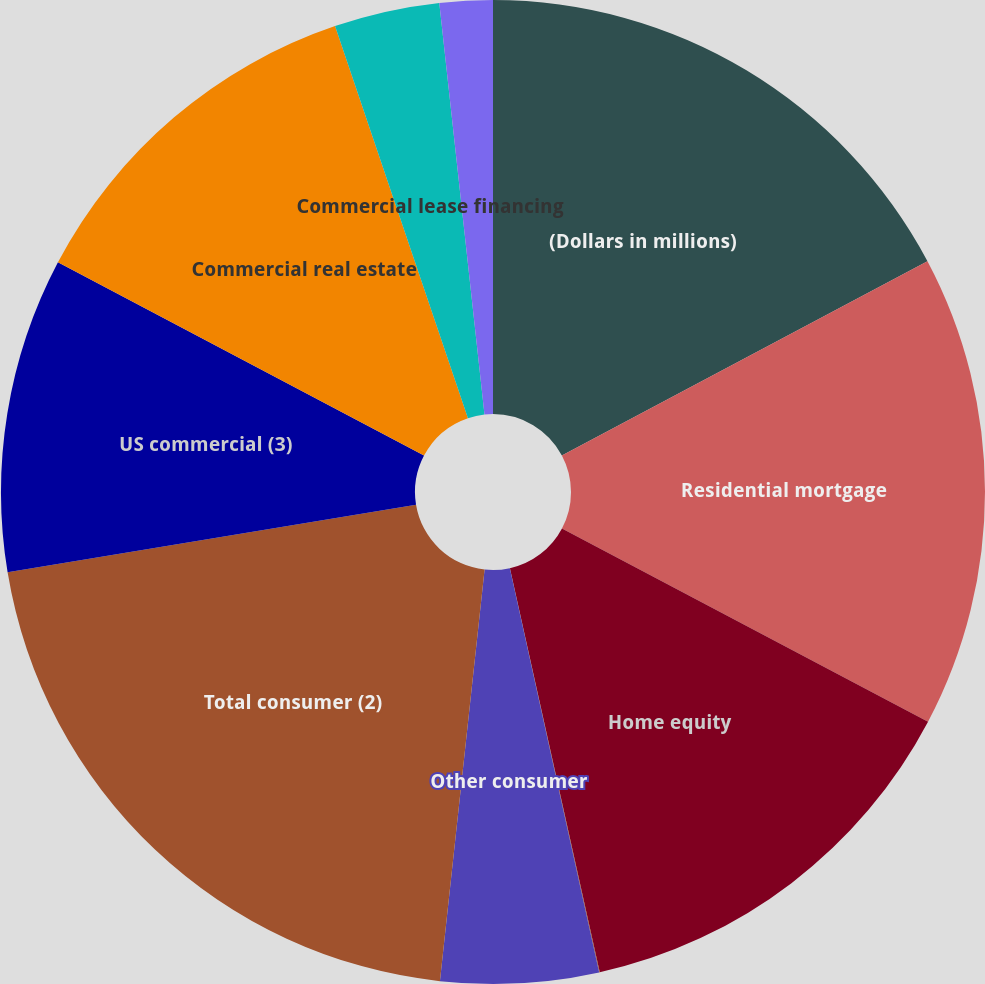<chart> <loc_0><loc_0><loc_500><loc_500><pie_chart><fcel>(Dollars in millions)<fcel>Residential mortgage<fcel>Home equity<fcel>Direct/Indirect consumer<fcel>Other consumer<fcel>Total consumer (2)<fcel>US commercial (3)<fcel>Commercial real estate<fcel>Commercial lease financing<fcel>Non-US commercial<nl><fcel>17.22%<fcel>15.5%<fcel>13.78%<fcel>0.02%<fcel>5.18%<fcel>20.66%<fcel>10.34%<fcel>12.06%<fcel>3.46%<fcel>1.74%<nl></chart> 